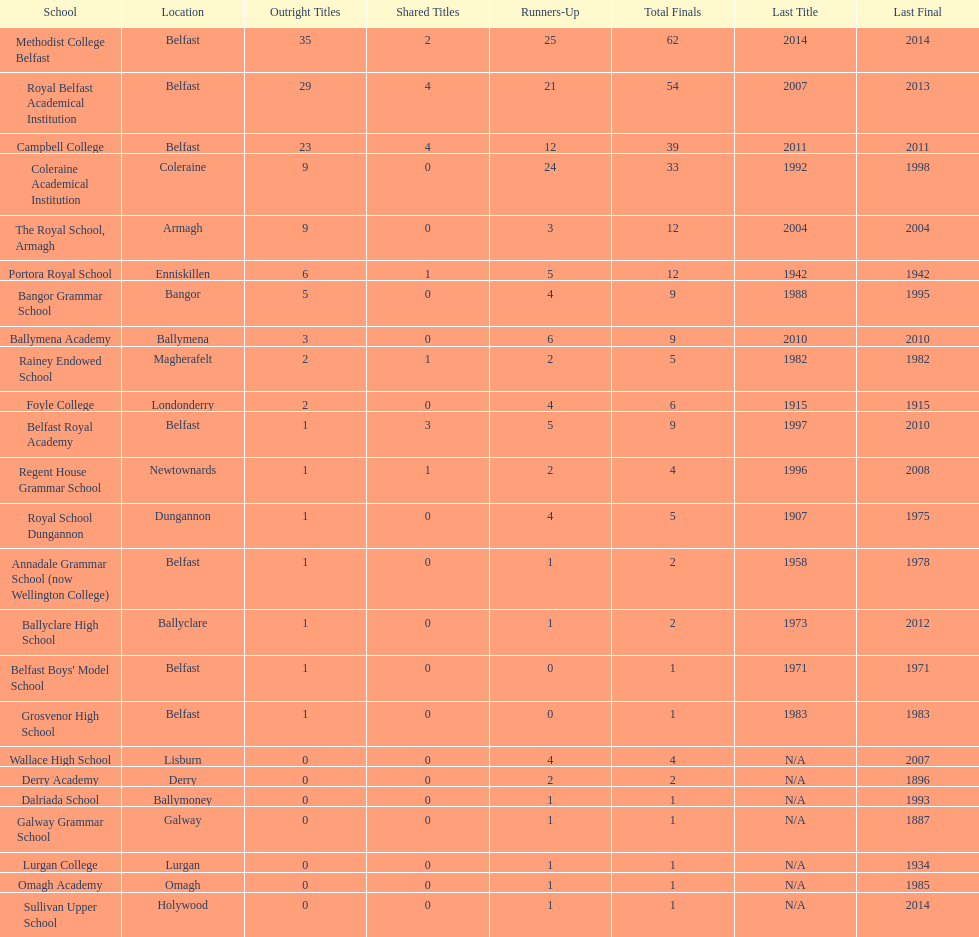Which school has the same number of outright titles as the coleraine academical institution? The Royal School, Armagh. 